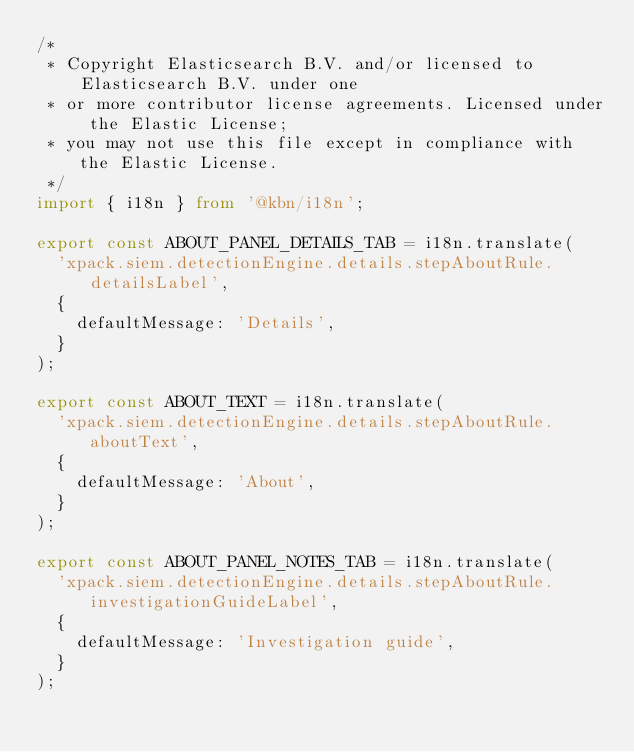Convert code to text. <code><loc_0><loc_0><loc_500><loc_500><_TypeScript_>/*
 * Copyright Elasticsearch B.V. and/or licensed to Elasticsearch B.V. under one
 * or more contributor license agreements. Licensed under the Elastic License;
 * you may not use this file except in compliance with the Elastic License.
 */
import { i18n } from '@kbn/i18n';

export const ABOUT_PANEL_DETAILS_TAB = i18n.translate(
  'xpack.siem.detectionEngine.details.stepAboutRule.detailsLabel',
  {
    defaultMessage: 'Details',
  }
);

export const ABOUT_TEXT = i18n.translate(
  'xpack.siem.detectionEngine.details.stepAboutRule.aboutText',
  {
    defaultMessage: 'About',
  }
);

export const ABOUT_PANEL_NOTES_TAB = i18n.translate(
  'xpack.siem.detectionEngine.details.stepAboutRule.investigationGuideLabel',
  {
    defaultMessage: 'Investigation guide',
  }
);
</code> 